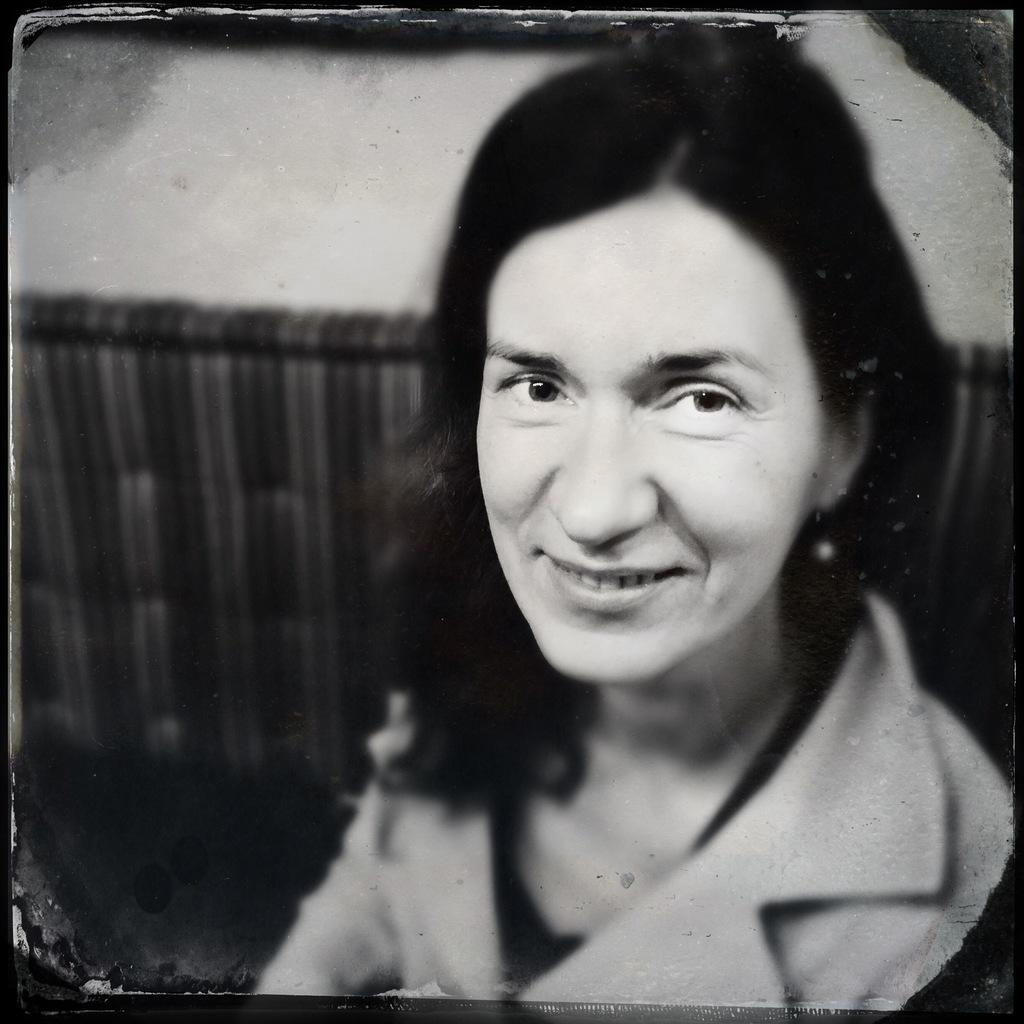What is the color scheme of the image? The image is black and white. What is the main subject of the image? There is a picture of a woman in the image. How loud is the band playing in the image? There is no band present in the image, so it is not possible to determine the volume of any music. 